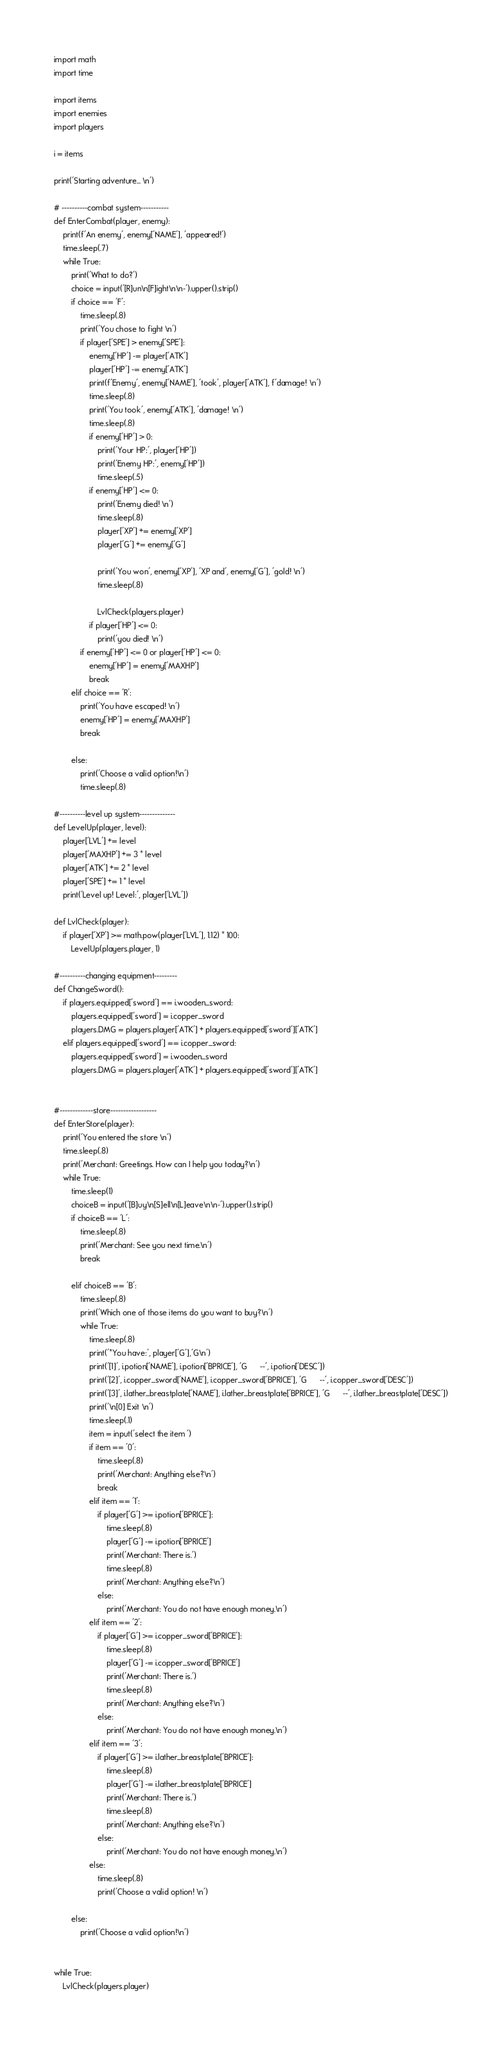Convert code to text. <code><loc_0><loc_0><loc_500><loc_500><_Python_>import math
import time

import items 
import enemies
import players

i = items

print('Starting adventure... \n')

# ----------combat system-----------
def EnterCombat(player, enemy):
    print(f'An enemy', enemy['NAME'], 'appeared!')
    time.sleep(.7)
    while True:
        print('What to do?')
        choice = input('[R]un\n[F]ight\n\n-').upper().strip()
        if choice == 'F':
            time.sleep(.8)
            print('You chose to fight \n')         
            if player['SPE'] > enemy['SPE']:
                enemy['HP'] -= player['ATK']
                player['HP'] -= enemy['ATK']
                print(f'Enemy', enemy['NAME'], 'took', player['ATK'], f'damage! \n')
                time.sleep(.8)
                print('You took', enemy['ATK'], 'damage! \n')
                time.sleep(.8)
                if enemy['HP'] > 0:
                    print('Your HP:', player['HP'])
                    print('Enemy HP:', enemy['HP'])
                    time.sleep(.5)
                if enemy['HP'] <= 0:
                    print('Enemy died! \n')
                    time.sleep(.8)
                    player['XP'] += enemy['XP']
                    player['G'] += enemy['G']
                    
                    print('You won', enemy['XP'], 'XP and', enemy['G'], 'gold! \n')
                    time.sleep(.8)
                    
                    LvlCheck(players.player)    
                if player['HP'] <= 0:
                	print('you died! \n')
            if enemy['HP'] <= 0 or player['HP'] <= 0:
                enemy['HP'] = enemy['MAXHP']  
                break
        elif choice == 'R':
            print('You have escaped! \n')
            enemy['HP'] = enemy['MAXHP']
            break

        else:
            print('Choose a valid option!\n')
            time.sleep(.8)

#----------level up system--------------
def LevelUp(player, level):
	player['LVL'] += level
	player['MAXHP'] += 3 * level
	player['ATK'] += 2 * level
	player['SPE'] += 1 * level
	print('Level up! Level:', player['LVL'])
	
def LvlCheck(player):
	if player['XP'] >= math.pow(player['LVL'], 1.12) * 100:
		LevelUp(players.player, 1)

#----------changing equipment---------
def ChangeSword():
    if players.equipped['sword'] == i.wooden_sword:
        players.equipped['sword'] = i.copper_sword
        players.DMG = players.player['ATK'] + players.equipped['sword']['ATK']
    elif players.equipped['sword'] == i.copper_sword:
        players.equipped['sword'] = i.wooden_sword
        players.DMG = players.player['ATK'] + players.equipped['sword']['ATK']
    

#-------------store------------------
def EnterStore(player):
    print('You entered the store \n')
    time.sleep(.8)
    print('Merchant: Greetings. How can I help you today?\n')
    while True:
        time.sleep(1)
        choiceB = input('[B]uy\n[S]ell\n[L]eave\n\n-').upper().strip()
        if choiceB == 'L':
            time.sleep(.8)
            print('Merchant: See you next time.\n')
            break
			
        elif choiceB == 'B':
            time.sleep(.8)
            print('Which one of those items do you want to buy?\n')
            while True:
                time.sleep(.8)
                print('*You have:', player['G'],'G\n')
                print('[1]', i.potion['NAME'], i.potion['BPRICE'], 'G      --', i.potion['DESC'])
                print('[2]', i.copper_sword['NAME'], i.copper_sword['BPRICE'], 'G      --', i.copper_sword['DESC'])
                print('[3]', i.lather_breastplate['NAME'], i.lather_breastplate['BPRICE'], 'G      --', i.lather_breastplate['DESC'])
                print('\n[0] Exit \n')
                time.sleep(.1)
                item = input('select the item ')
                if item == '0':
                    time.sleep(.8)
                    print('Merchant: Anything else?\n')
                    break
                elif item == '1':
                    if player['G'] >= i.potion['BPRICE']:
                        time.sleep(.8)
                        player['G'] -= i.potion['BPRICE']
                        print('Merchant: There is.')
                        time.sleep(.8)
                        print('Merchant: Anything else?\n')
                    else:
                        print('Merchant: You do not have enough money.\n')
                elif item == '2':
                    if player['G'] >= i.copper_sword['BPRICE']:
                        time.sleep(.8)
                        player['G'] -= i.copper_sword['BPRICE']
                        print('Merchant: There is.')
                        time.sleep(.8)
                        print('Merchant: Anything else?\n')
                    else:
                        print('Merchant: You do not have enough money.\n')
                elif item == '3':
                    if player['G'] >= i.lather_breastplate['BPRICE']:
                        time.sleep(.8)
                        player['G'] -= i.lather_breastplate['BPRICE']
                        print('Merchant: There is.')
                        time.sleep(.8)
                        print('Merchant: Anything else?\n')
                    else:
                        print('Merchant: You do not have enough money.\n')
                else:
                    time.sleep(.8)
                    print('Choose a valid option! \n')
				
        else:
            print('Choose a valid option!\n')


while True:
    LvlCheck(players.player)</code> 